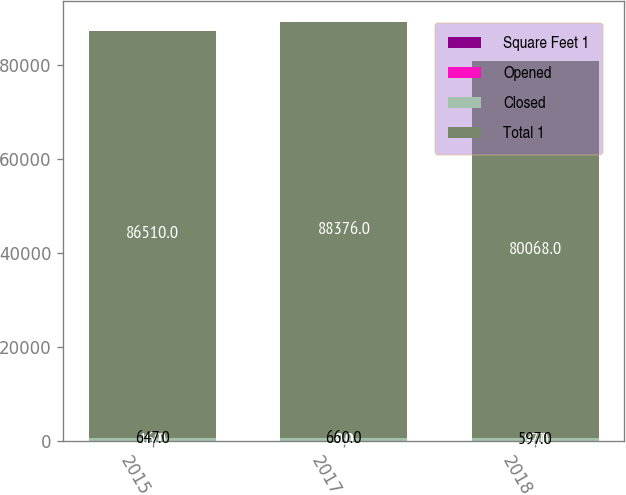<chart> <loc_0><loc_0><loc_500><loc_500><stacked_bar_chart><ecel><fcel>2015<fcel>2017<fcel>2018<nl><fcel>Square Feet 1<fcel>16<fcel>9<fcel>4<nl><fcel>Opened<fcel>1<fcel>4<fcel>67<nl><fcel>Closed<fcel>647<fcel>660<fcel>597<nl><fcel>Total 1<fcel>86510<fcel>88376<fcel>80068<nl></chart> 